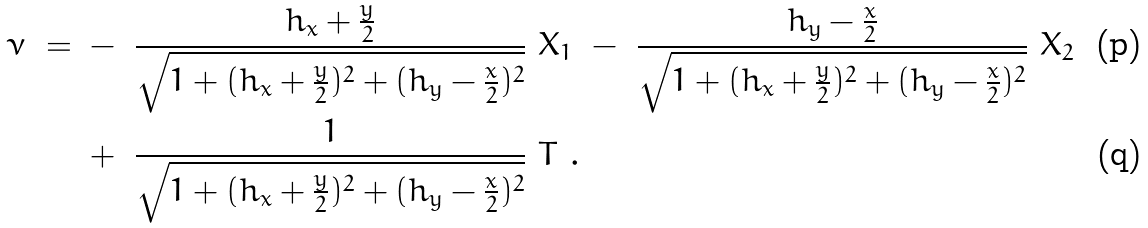<formula> <loc_0><loc_0><loc_500><loc_500>\nu \ = \ & - \ \frac { h _ { x } + \frac { y } { 2 } } { \sqrt { 1 + ( h _ { x } + \frac { y } { 2 } ) ^ { 2 } + ( h _ { y } - \frac { x } { 2 } ) ^ { 2 } } } \ { X _ { 1 } } \ - \ \frac { h _ { y } - \frac { x } { 2 } } { \sqrt { 1 + ( h _ { x } + \frac { y } { 2 } ) ^ { 2 } + ( h _ { y } - \frac { x } { 2 } ) ^ { 2 } } } \ { X _ { 2 } } \\ & + \ \frac { 1 } { \sqrt { 1 + ( h _ { x } + \frac { y } { 2 } ) ^ { 2 } + ( h _ { y } - \frac { x } { 2 } ) ^ { 2 } } } \ T \ .</formula> 